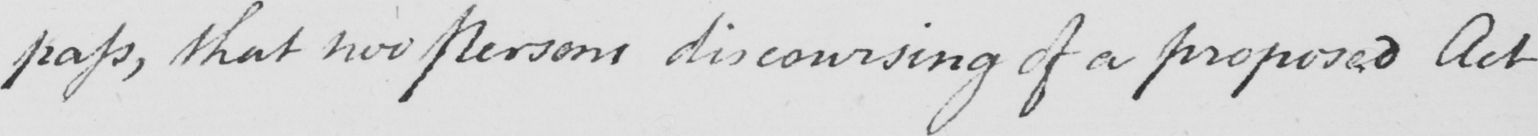Can you read and transcribe this handwriting? pass , that now persons discoursing of a proposed Act 